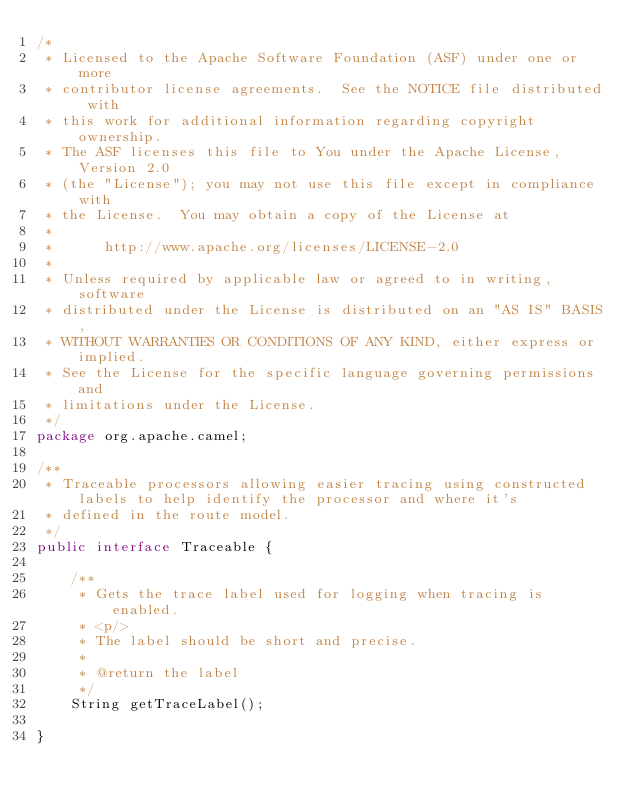<code> <loc_0><loc_0><loc_500><loc_500><_Java_>/*
 * Licensed to the Apache Software Foundation (ASF) under one or more
 * contributor license agreements.  See the NOTICE file distributed with
 * this work for additional information regarding copyright ownership.
 * The ASF licenses this file to You under the Apache License, Version 2.0
 * (the "License"); you may not use this file except in compliance with
 * the License.  You may obtain a copy of the License at
 *
 *      http://www.apache.org/licenses/LICENSE-2.0
 *
 * Unless required by applicable law or agreed to in writing, software
 * distributed under the License is distributed on an "AS IS" BASIS,
 * WITHOUT WARRANTIES OR CONDITIONS OF ANY KIND, either express or implied.
 * See the License for the specific language governing permissions and
 * limitations under the License.
 */
package org.apache.camel;

/**
 * Traceable processors allowing easier tracing using constructed labels to help identify the processor and where it's
 * defined in the route model.
 */
public interface Traceable {

    /**
     * Gets the trace label used for logging when tracing is enabled.
     * <p/>
     * The label should be short and precise.
     *
     * @return the label
     */
    String getTraceLabel();

}
</code> 